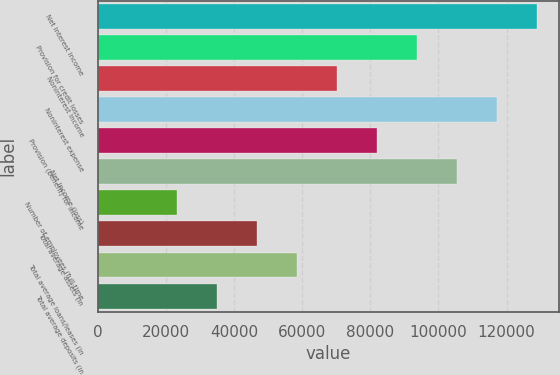Convert chart. <chart><loc_0><loc_0><loc_500><loc_500><bar_chart><fcel>Net interest income<fcel>Provision for credit losses<fcel>Noninterest income<fcel>Noninterest expense<fcel>Provision (benefit) for income<fcel>Net income (loss)<fcel>Number of employees (full-time<fcel>Total average assets (in<fcel>Total average loans/leases (in<fcel>Total average deposits (in<nl><fcel>128833<fcel>93696.8<fcel>70272.7<fcel>117121<fcel>81984.8<fcel>105409<fcel>23424.4<fcel>46848.5<fcel>58560.6<fcel>35136.5<nl></chart> 